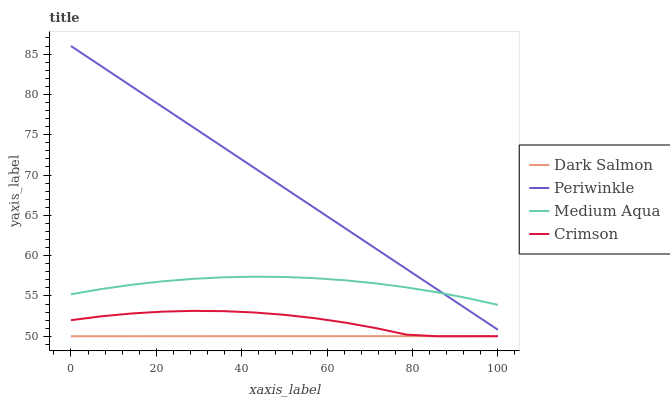Does Dark Salmon have the minimum area under the curve?
Answer yes or no. Yes. Does Periwinkle have the maximum area under the curve?
Answer yes or no. Yes. Does Medium Aqua have the minimum area under the curve?
Answer yes or no. No. Does Medium Aqua have the maximum area under the curve?
Answer yes or no. No. Is Dark Salmon the smoothest?
Answer yes or no. Yes. Is Crimson the roughest?
Answer yes or no. Yes. Is Medium Aqua the smoothest?
Answer yes or no. No. Is Medium Aqua the roughest?
Answer yes or no. No. Does Crimson have the lowest value?
Answer yes or no. Yes. Does Periwinkle have the lowest value?
Answer yes or no. No. Does Periwinkle have the highest value?
Answer yes or no. Yes. Does Medium Aqua have the highest value?
Answer yes or no. No. Is Dark Salmon less than Medium Aqua?
Answer yes or no. Yes. Is Periwinkle greater than Dark Salmon?
Answer yes or no. Yes. Does Dark Salmon intersect Crimson?
Answer yes or no. Yes. Is Dark Salmon less than Crimson?
Answer yes or no. No. Is Dark Salmon greater than Crimson?
Answer yes or no. No. Does Dark Salmon intersect Medium Aqua?
Answer yes or no. No. 